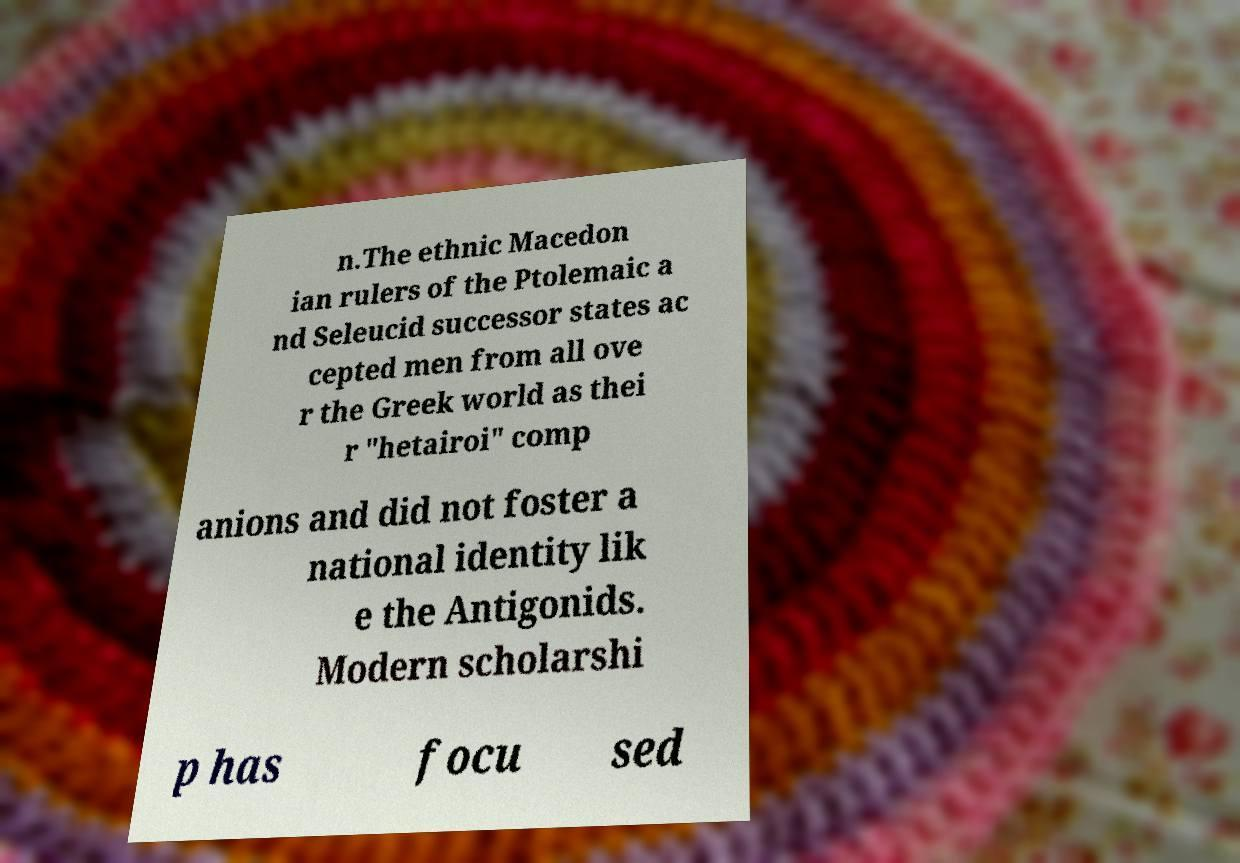I need the written content from this picture converted into text. Can you do that? n.The ethnic Macedon ian rulers of the Ptolemaic a nd Seleucid successor states ac cepted men from all ove r the Greek world as thei r "hetairoi" comp anions and did not foster a national identity lik e the Antigonids. Modern scholarshi p has focu sed 